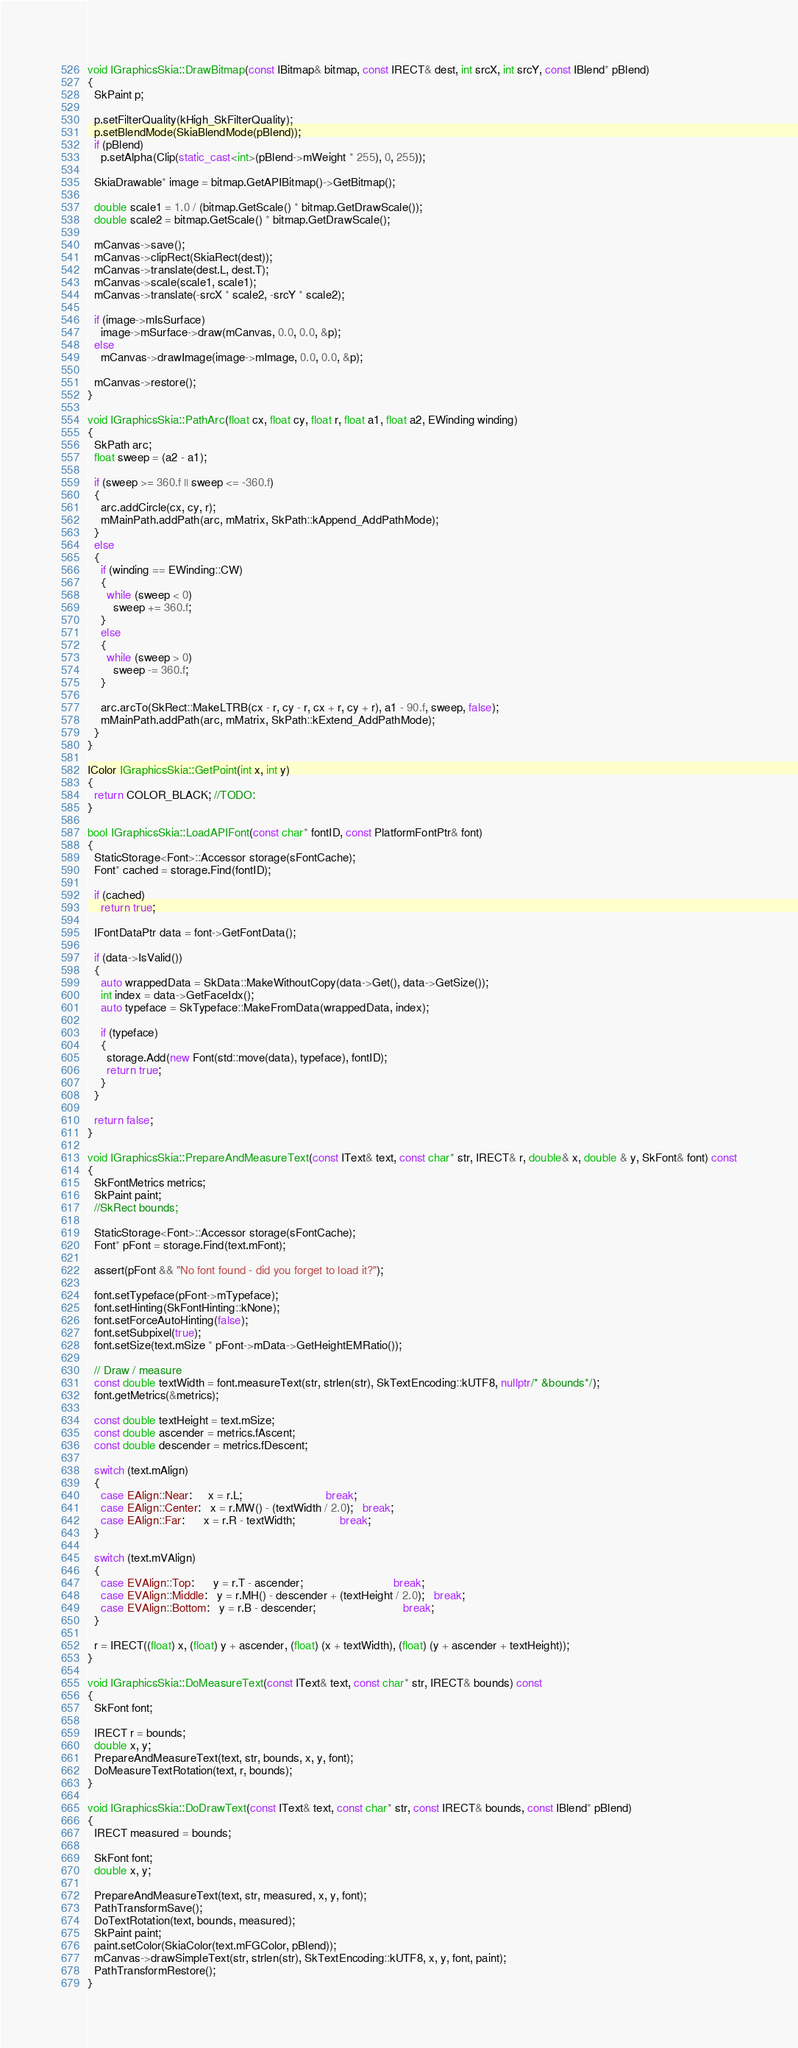Convert code to text. <code><loc_0><loc_0><loc_500><loc_500><_C++_>
void IGraphicsSkia::DrawBitmap(const IBitmap& bitmap, const IRECT& dest, int srcX, int srcY, const IBlend* pBlend)
{
  SkPaint p;
  
  p.setFilterQuality(kHigh_SkFilterQuality);
  p.setBlendMode(SkiaBlendMode(pBlend));
  if (pBlend)
    p.setAlpha(Clip(static_cast<int>(pBlend->mWeight * 255), 0, 255));
    
  SkiaDrawable* image = bitmap.GetAPIBitmap()->GetBitmap();

  double scale1 = 1.0 / (bitmap.GetScale() * bitmap.GetDrawScale());
  double scale2 = bitmap.GetScale() * bitmap.GetDrawScale();
  
  mCanvas->save();
  mCanvas->clipRect(SkiaRect(dest));
  mCanvas->translate(dest.L, dest.T);
  mCanvas->scale(scale1, scale1);
  mCanvas->translate(-srcX * scale2, -srcY * scale2);
  
  if (image->mIsSurface)
    image->mSurface->draw(mCanvas, 0.0, 0.0, &p);
  else
    mCanvas->drawImage(image->mImage, 0.0, 0.0, &p);
    
  mCanvas->restore();
}

void IGraphicsSkia::PathArc(float cx, float cy, float r, float a1, float a2, EWinding winding)
{
  SkPath arc;
  float sweep = (a2 - a1);

  if (sweep >= 360.f || sweep <= -360.f)
  {
    arc.addCircle(cx, cy, r);
    mMainPath.addPath(arc, mMatrix, SkPath::kAppend_AddPathMode);
  }
  else
  {
    if (winding == EWinding::CW)
    {
      while (sweep < 0)
        sweep += 360.f;
    }
    else
    {
      while (sweep > 0)
        sweep -= 360.f;
    }
      
    arc.arcTo(SkRect::MakeLTRB(cx - r, cy - r, cx + r, cy + r), a1 - 90.f, sweep, false);
    mMainPath.addPath(arc, mMatrix, SkPath::kExtend_AddPathMode);
  }
}

IColor IGraphicsSkia::GetPoint(int x, int y)
{
  return COLOR_BLACK; //TODO:
}

bool IGraphicsSkia::LoadAPIFont(const char* fontID, const PlatformFontPtr& font)
{
  StaticStorage<Font>::Accessor storage(sFontCache);
  Font* cached = storage.Find(fontID);
  
  if (cached)
    return true;
  
  IFontDataPtr data = font->GetFontData();
  
  if (data->IsValid())
  {
    auto wrappedData = SkData::MakeWithoutCopy(data->Get(), data->GetSize());
    int index = data->GetFaceIdx();
    auto typeface = SkTypeface::MakeFromData(wrappedData, index);
    
    if (typeface)
    {
      storage.Add(new Font(std::move(data), typeface), fontID);
      return true;
    }
  }
  
  return false;
}

void IGraphicsSkia::PrepareAndMeasureText(const IText& text, const char* str, IRECT& r, double& x, double & y, SkFont& font) const
{
  SkFontMetrics metrics;
  SkPaint paint;
  //SkRect bounds;
  
  StaticStorage<Font>::Accessor storage(sFontCache);
  Font* pFont = storage.Find(text.mFont);
  
  assert(pFont && "No font found - did you forget to load it?");

  font.setTypeface(pFont->mTypeface);
  font.setHinting(SkFontHinting::kNone);
  font.setForceAutoHinting(false);
  font.setSubpixel(true);
  font.setSize(text.mSize * pFont->mData->GetHeightEMRatio());
  
  // Draw / measure
  const double textWidth = font.measureText(str, strlen(str), SkTextEncoding::kUTF8, nullptr/* &bounds*/);
  font.getMetrics(&metrics);
  
  const double textHeight = text.mSize;
  const double ascender = metrics.fAscent;
  const double descender = metrics.fDescent;
  
  switch (text.mAlign)
  {
    case EAlign::Near:     x = r.L;                          break;
    case EAlign::Center:   x = r.MW() - (textWidth / 2.0);   break;
    case EAlign::Far:      x = r.R - textWidth;              break;
  }
  
  switch (text.mVAlign)
  {
    case EVAlign::Top:      y = r.T - ascender;                            break;
    case EVAlign::Middle:   y = r.MH() - descender + (textHeight / 2.0);   break;
    case EVAlign::Bottom:   y = r.B - descender;                           break;
  }
  
  r = IRECT((float) x, (float) y + ascender, (float) (x + textWidth), (float) (y + ascender + textHeight));
}

void IGraphicsSkia::DoMeasureText(const IText& text, const char* str, IRECT& bounds) const
{
  SkFont font;

  IRECT r = bounds;
  double x, y;
  PrepareAndMeasureText(text, str, bounds, x, y, font);
  DoMeasureTextRotation(text, r, bounds);
}

void IGraphicsSkia::DoDrawText(const IText& text, const char* str, const IRECT& bounds, const IBlend* pBlend)
{
  IRECT measured = bounds;
  
  SkFont font;
  double x, y;
  
  PrepareAndMeasureText(text, str, measured, x, y, font);
  PathTransformSave();
  DoTextRotation(text, bounds, measured);
  SkPaint paint;
  paint.setColor(SkiaColor(text.mFGColor, pBlend));
  mCanvas->drawSimpleText(str, strlen(str), SkTextEncoding::kUTF8, x, y, font, paint);
  PathTransformRestore();
}
</code> 